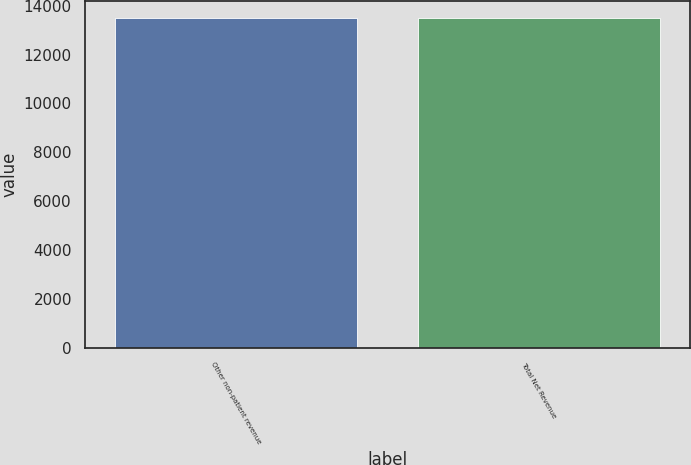Convert chart. <chart><loc_0><loc_0><loc_500><loc_500><bar_chart><fcel>Other non-patient revenue<fcel>Total Net Revenue<nl><fcel>13499<fcel>13499.1<nl></chart> 